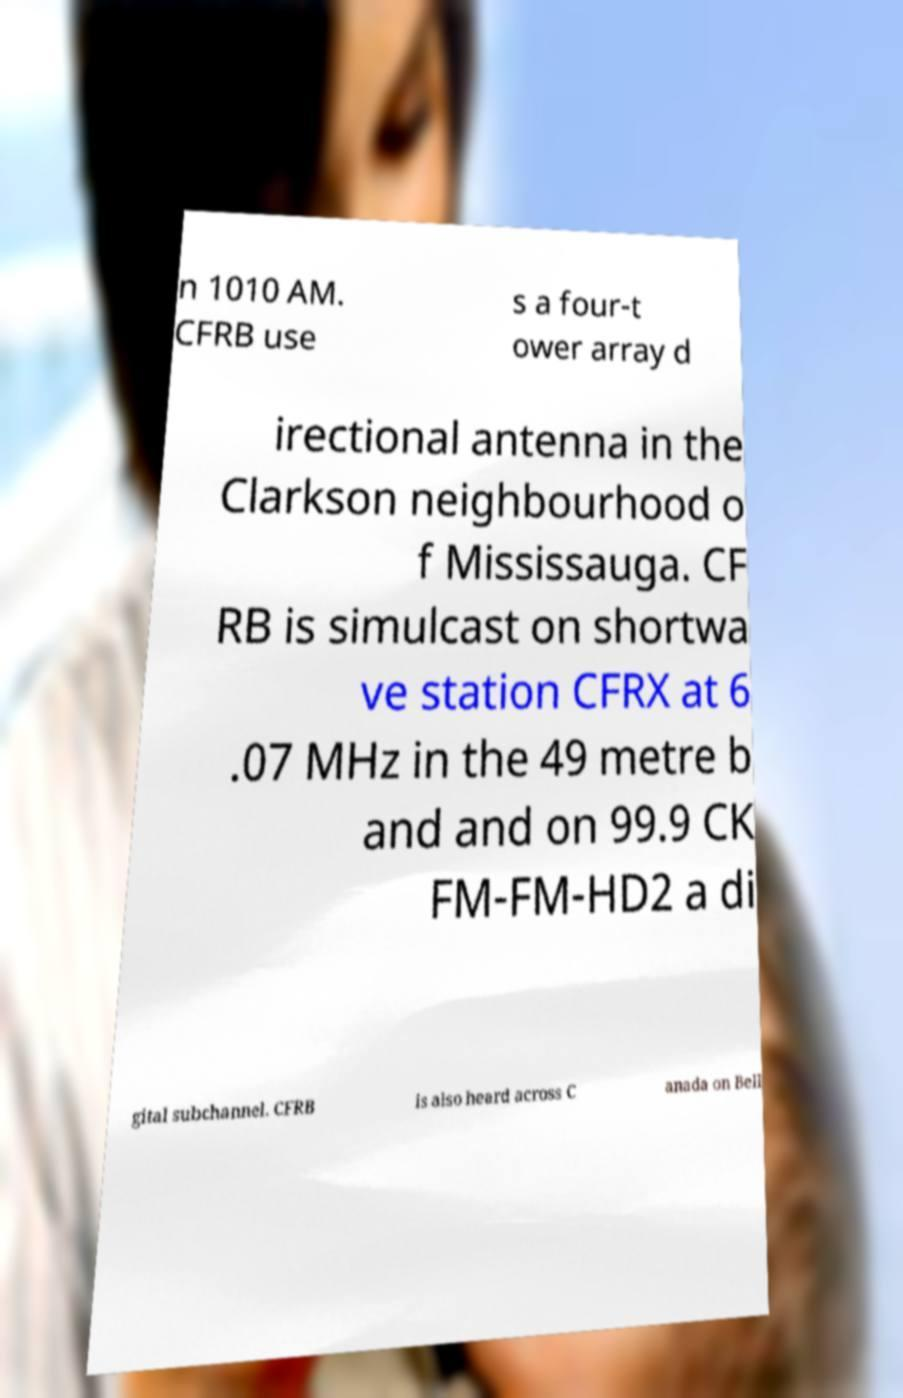Please read and relay the text visible in this image. What does it say? n 1010 AM. CFRB use s a four-t ower array d irectional antenna in the Clarkson neighbourhood o f Mississauga. CF RB is simulcast on shortwa ve station CFRX at 6 .07 MHz in the 49 metre b and and on 99.9 CK FM-FM-HD2 a di gital subchannel. CFRB is also heard across C anada on Bell 